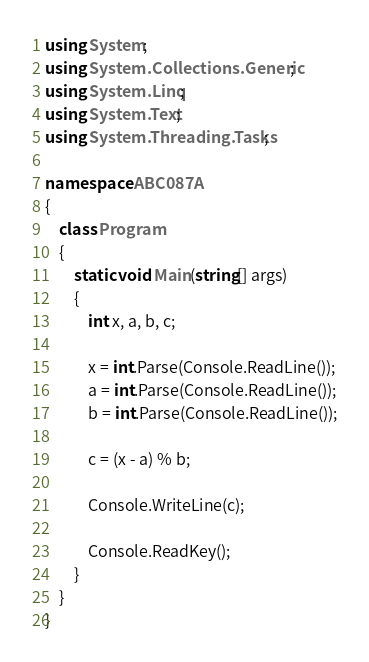<code> <loc_0><loc_0><loc_500><loc_500><_C#_>using System;
using System.Collections.Generic;
using System.Linq;
using System.Text;
using System.Threading.Tasks;

namespace ABC087A
{
    class Program
    {
        static void Main(string[] args)
        {
            int x, a, b, c;

            x = int.Parse(Console.ReadLine());
            a = int.Parse(Console.ReadLine());
            b = int.Parse(Console.ReadLine());

            c = (x - a) % b;

            Console.WriteLine(c);

            Console.ReadKey();
        }
    }
}</code> 